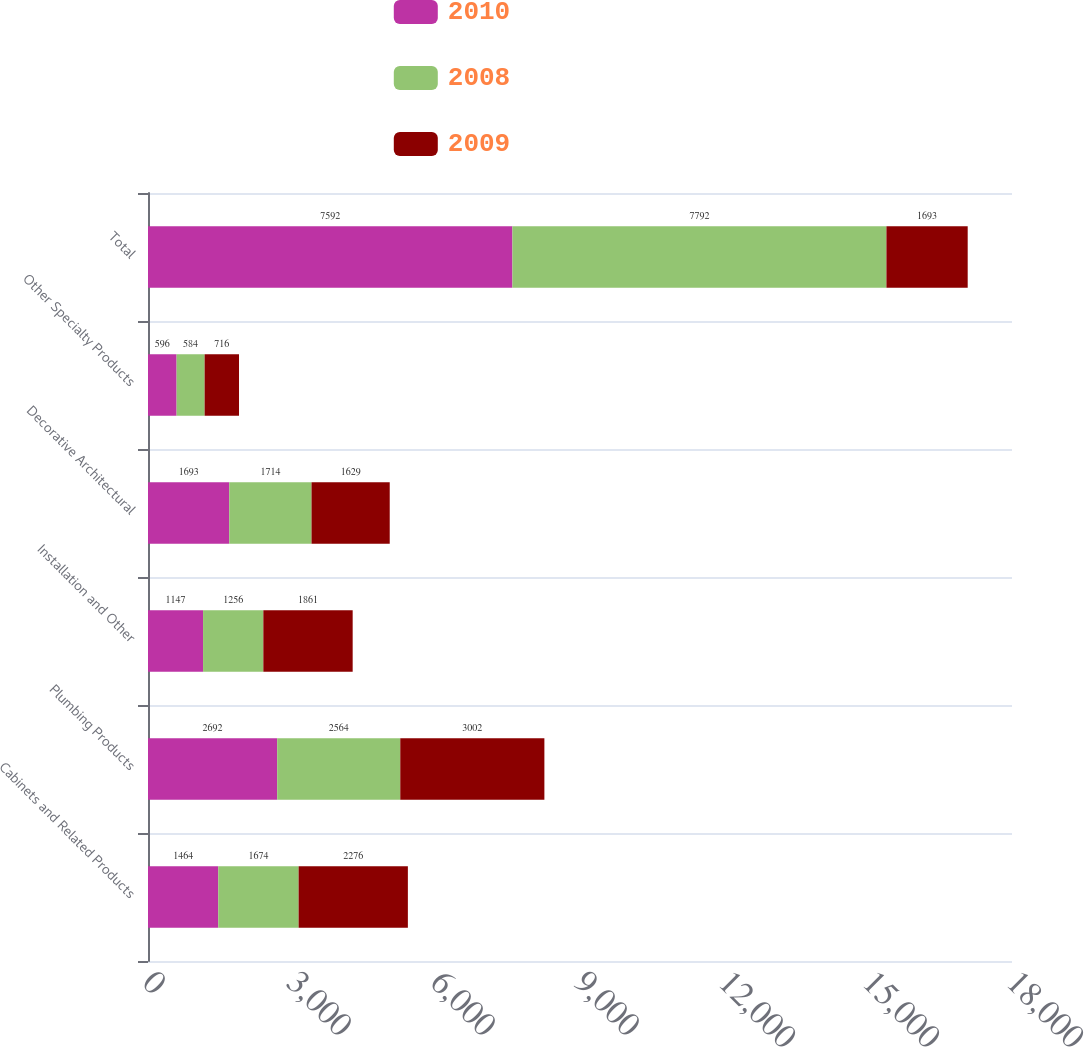Convert chart to OTSL. <chart><loc_0><loc_0><loc_500><loc_500><stacked_bar_chart><ecel><fcel>Cabinets and Related Products<fcel>Plumbing Products<fcel>Installation and Other<fcel>Decorative Architectural<fcel>Other Specialty Products<fcel>Total<nl><fcel>2010<fcel>1464<fcel>2692<fcel>1147<fcel>1693<fcel>596<fcel>7592<nl><fcel>2008<fcel>1674<fcel>2564<fcel>1256<fcel>1714<fcel>584<fcel>7792<nl><fcel>2009<fcel>2276<fcel>3002<fcel>1861<fcel>1629<fcel>716<fcel>1693<nl></chart> 